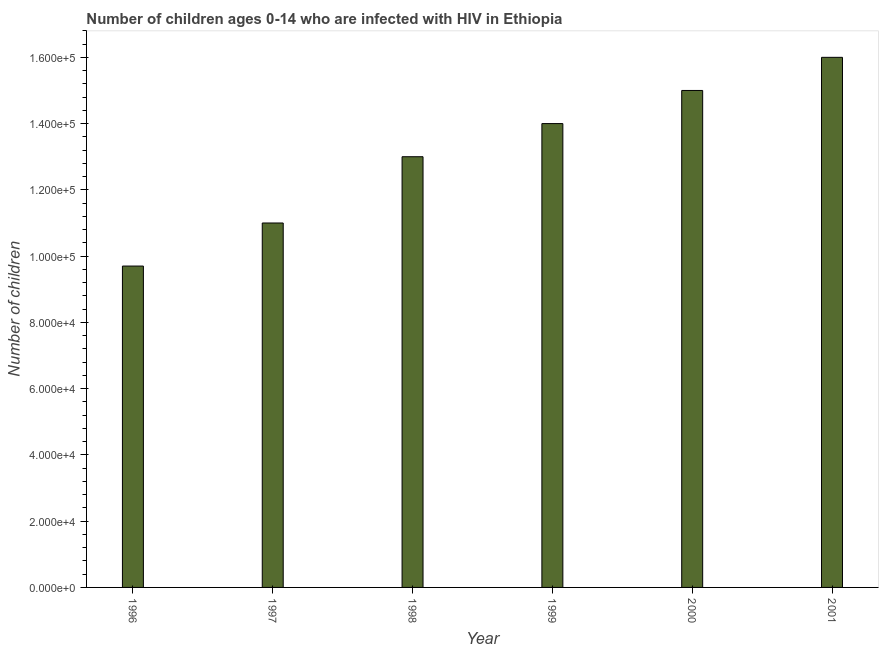What is the title of the graph?
Provide a short and direct response. Number of children ages 0-14 who are infected with HIV in Ethiopia. What is the label or title of the Y-axis?
Make the answer very short. Number of children. What is the number of children living with hiv in 1996?
Your answer should be compact. 9.70e+04. Across all years, what is the minimum number of children living with hiv?
Your response must be concise. 9.70e+04. In which year was the number of children living with hiv maximum?
Offer a very short reply. 2001. What is the sum of the number of children living with hiv?
Provide a succinct answer. 7.87e+05. What is the average number of children living with hiv per year?
Offer a terse response. 1.31e+05. What is the median number of children living with hiv?
Ensure brevity in your answer.  1.35e+05. Do a majority of the years between 1999 and 1998 (inclusive) have number of children living with hiv greater than 20000 ?
Offer a terse response. No. What is the ratio of the number of children living with hiv in 1996 to that in 2000?
Provide a succinct answer. 0.65. Is the number of children living with hiv in 1999 less than that in 2001?
Your response must be concise. Yes. What is the difference between the highest and the second highest number of children living with hiv?
Offer a terse response. 10000. Is the sum of the number of children living with hiv in 1997 and 1998 greater than the maximum number of children living with hiv across all years?
Give a very brief answer. Yes. What is the difference between the highest and the lowest number of children living with hiv?
Your answer should be very brief. 6.30e+04. In how many years, is the number of children living with hiv greater than the average number of children living with hiv taken over all years?
Offer a very short reply. 3. How many bars are there?
Offer a very short reply. 6. Are all the bars in the graph horizontal?
Ensure brevity in your answer.  No. How many years are there in the graph?
Your response must be concise. 6. What is the Number of children of 1996?
Your answer should be very brief. 9.70e+04. What is the Number of children in 1997?
Ensure brevity in your answer.  1.10e+05. What is the Number of children in 1998?
Your response must be concise. 1.30e+05. What is the Number of children in 2001?
Make the answer very short. 1.60e+05. What is the difference between the Number of children in 1996 and 1997?
Give a very brief answer. -1.30e+04. What is the difference between the Number of children in 1996 and 1998?
Offer a terse response. -3.30e+04. What is the difference between the Number of children in 1996 and 1999?
Ensure brevity in your answer.  -4.30e+04. What is the difference between the Number of children in 1996 and 2000?
Offer a very short reply. -5.30e+04. What is the difference between the Number of children in 1996 and 2001?
Your response must be concise. -6.30e+04. What is the difference between the Number of children in 1997 and 1998?
Offer a terse response. -2.00e+04. What is the difference between the Number of children in 1997 and 2000?
Offer a very short reply. -4.00e+04. What is the difference between the Number of children in 1998 and 1999?
Make the answer very short. -10000. What is the difference between the Number of children in 1998 and 2001?
Give a very brief answer. -3.00e+04. What is the ratio of the Number of children in 1996 to that in 1997?
Give a very brief answer. 0.88. What is the ratio of the Number of children in 1996 to that in 1998?
Make the answer very short. 0.75. What is the ratio of the Number of children in 1996 to that in 1999?
Ensure brevity in your answer.  0.69. What is the ratio of the Number of children in 1996 to that in 2000?
Make the answer very short. 0.65. What is the ratio of the Number of children in 1996 to that in 2001?
Offer a very short reply. 0.61. What is the ratio of the Number of children in 1997 to that in 1998?
Your answer should be very brief. 0.85. What is the ratio of the Number of children in 1997 to that in 1999?
Your answer should be very brief. 0.79. What is the ratio of the Number of children in 1997 to that in 2000?
Your response must be concise. 0.73. What is the ratio of the Number of children in 1997 to that in 2001?
Offer a very short reply. 0.69. What is the ratio of the Number of children in 1998 to that in 1999?
Offer a very short reply. 0.93. What is the ratio of the Number of children in 1998 to that in 2000?
Provide a short and direct response. 0.87. What is the ratio of the Number of children in 1998 to that in 2001?
Offer a very short reply. 0.81. What is the ratio of the Number of children in 1999 to that in 2000?
Give a very brief answer. 0.93. What is the ratio of the Number of children in 1999 to that in 2001?
Offer a terse response. 0.88. What is the ratio of the Number of children in 2000 to that in 2001?
Keep it short and to the point. 0.94. 